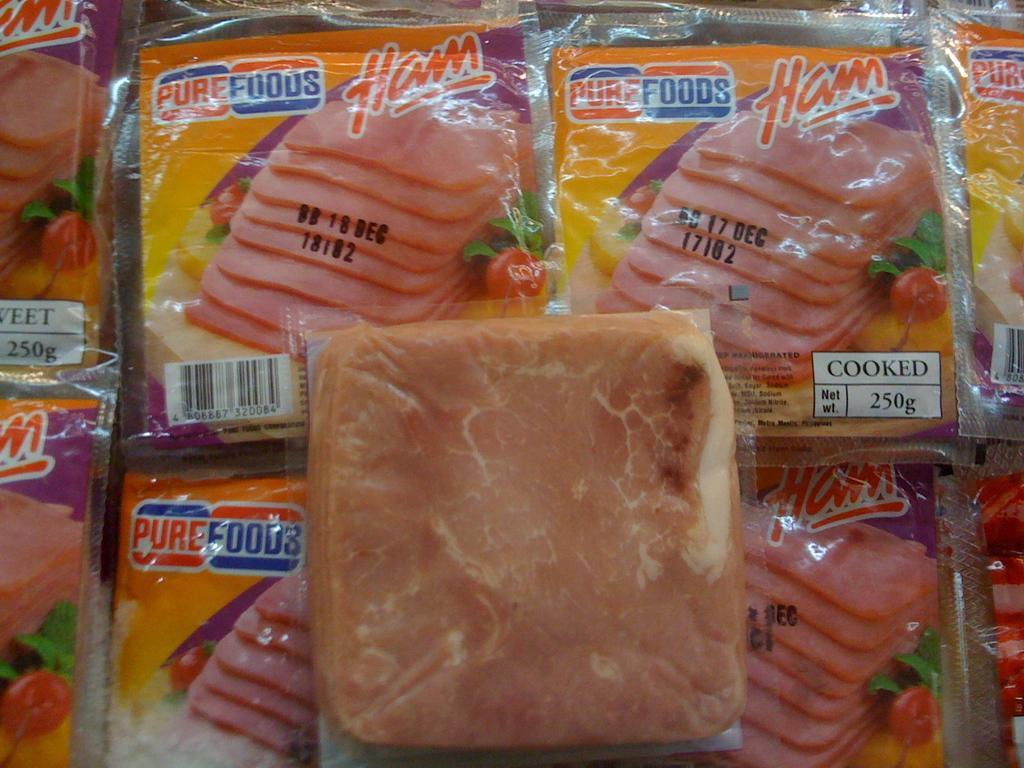Please provide a concise description of this image. In the image in the center, we can see few packets. In the packets, we can see some food items. And we can see something written on the packet. 